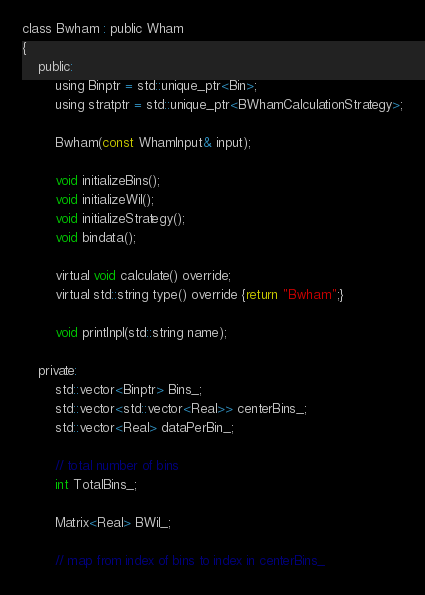Convert code to text. <code><loc_0><loc_0><loc_500><loc_500><_C_>
class Bwham : public Wham
{
    public:
        using Binptr = std::unique_ptr<Bin>; 
        using stratptr = std::unique_ptr<BWhamCalculationStrategy>;

        Bwham(const WhamInput& input);

        void initializeBins();
        void initializeWil();
        void initializeStrategy();
        void bindata();

        virtual void calculate() override;
        virtual std::string type() override {return "Bwham";}

        void printlnpl(std::string name);
    
    private:
        std::vector<Binptr> Bins_;
        std::vector<std::vector<Real>> centerBins_;
        std::vector<Real> dataPerBin_;

        // total number of bins
        int TotalBins_;

        Matrix<Real> BWil_;

        // map from index of bins to index in centerBins_</code> 